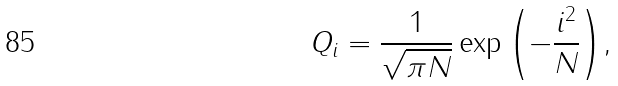<formula> <loc_0><loc_0><loc_500><loc_500>Q _ { i } = \frac { 1 } { \sqrt { \pi N } } \exp { \left ( - \frac { i ^ { 2 } } { N } \right ) } ,</formula> 